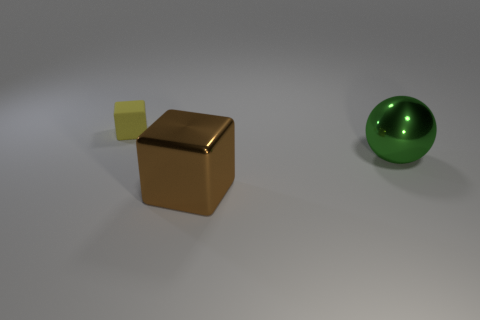What materials do the objects in the image appear to be made from? The objects in the image appear to have different textures. The brown cube has a reflective surface that suggests a metallic material, the yellow cube appears to have a matte finish likely indicating a plastic or rubber material, and the green sphere has a smooth, possibly glass-like surface with some reflections. 